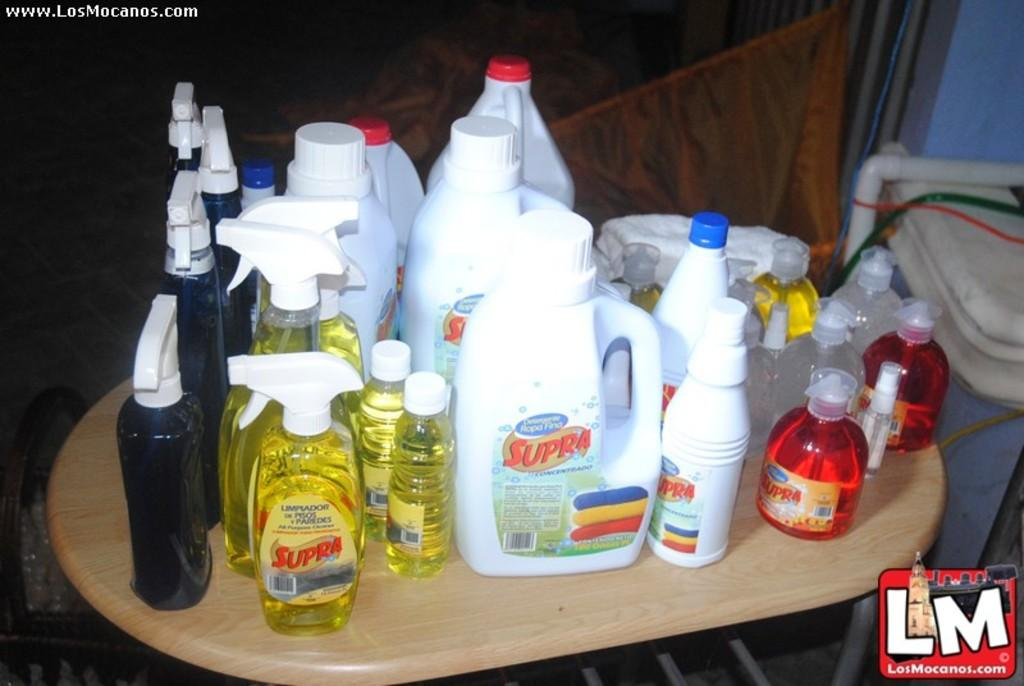<image>
Render a clear and concise summary of the photo. Many bottles of Supra brand cleaning products on a table. 